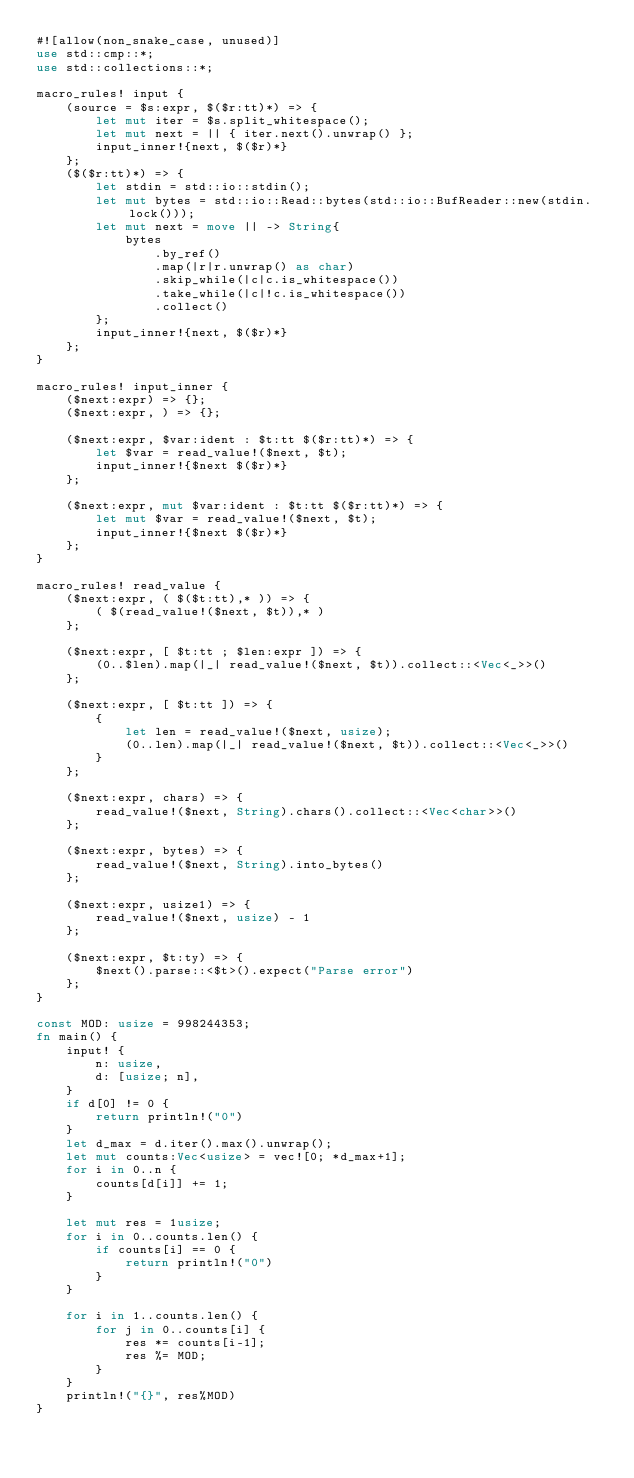<code> <loc_0><loc_0><loc_500><loc_500><_Rust_>#![allow(non_snake_case, unused)]
use std::cmp::*;
use std::collections::*;

macro_rules! input {
    (source = $s:expr, $($r:tt)*) => {
        let mut iter = $s.split_whitespace();
        let mut next = || { iter.next().unwrap() };
        input_inner!{next, $($r)*}
    };
    ($($r:tt)*) => {
        let stdin = std::io::stdin();
        let mut bytes = std::io::Read::bytes(std::io::BufReader::new(stdin.lock()));
        let mut next = move || -> String{
            bytes
                .by_ref()
                .map(|r|r.unwrap() as char)
                .skip_while(|c|c.is_whitespace())
                .take_while(|c|!c.is_whitespace())
                .collect()
        };
        input_inner!{next, $($r)*}
    };
}

macro_rules! input_inner {
    ($next:expr) => {};
    ($next:expr, ) => {};

    ($next:expr, $var:ident : $t:tt $($r:tt)*) => {
        let $var = read_value!($next, $t);
        input_inner!{$next $($r)*}
    };

    ($next:expr, mut $var:ident : $t:tt $($r:tt)*) => {
        let mut $var = read_value!($next, $t);
        input_inner!{$next $($r)*}
    };
}

macro_rules! read_value {
    ($next:expr, ( $($t:tt),* )) => {
        ( $(read_value!($next, $t)),* )
    };

    ($next:expr, [ $t:tt ; $len:expr ]) => {
        (0..$len).map(|_| read_value!($next, $t)).collect::<Vec<_>>()
    };

    ($next:expr, [ $t:tt ]) => {
        {
            let len = read_value!($next, usize);
            (0..len).map(|_| read_value!($next, $t)).collect::<Vec<_>>()
        }
    };

    ($next:expr, chars) => {
        read_value!($next, String).chars().collect::<Vec<char>>()
    };

    ($next:expr, bytes) => {
        read_value!($next, String).into_bytes()
    };

    ($next:expr, usize1) => {
        read_value!($next, usize) - 1
    };

    ($next:expr, $t:ty) => {
        $next().parse::<$t>().expect("Parse error")
    };
}

const MOD: usize = 998244353;
fn main() {
    input! {
        n: usize,
        d: [usize; n],
    }
    if d[0] != 0 {
        return println!("0")
    }
    let d_max = d.iter().max().unwrap();
    let mut counts:Vec<usize> = vec![0; *d_max+1];
    for i in 0..n {
        counts[d[i]] += 1;
    }

    let mut res = 1usize;
    for i in 0..counts.len() {
        if counts[i] == 0 {
            return println!("0")
        }
    }

    for i in 1..counts.len() {
        for j in 0..counts[i] {
            res *= counts[i-1];
            res %= MOD;
        }
    }
    println!("{}", res%MOD)
}

</code> 